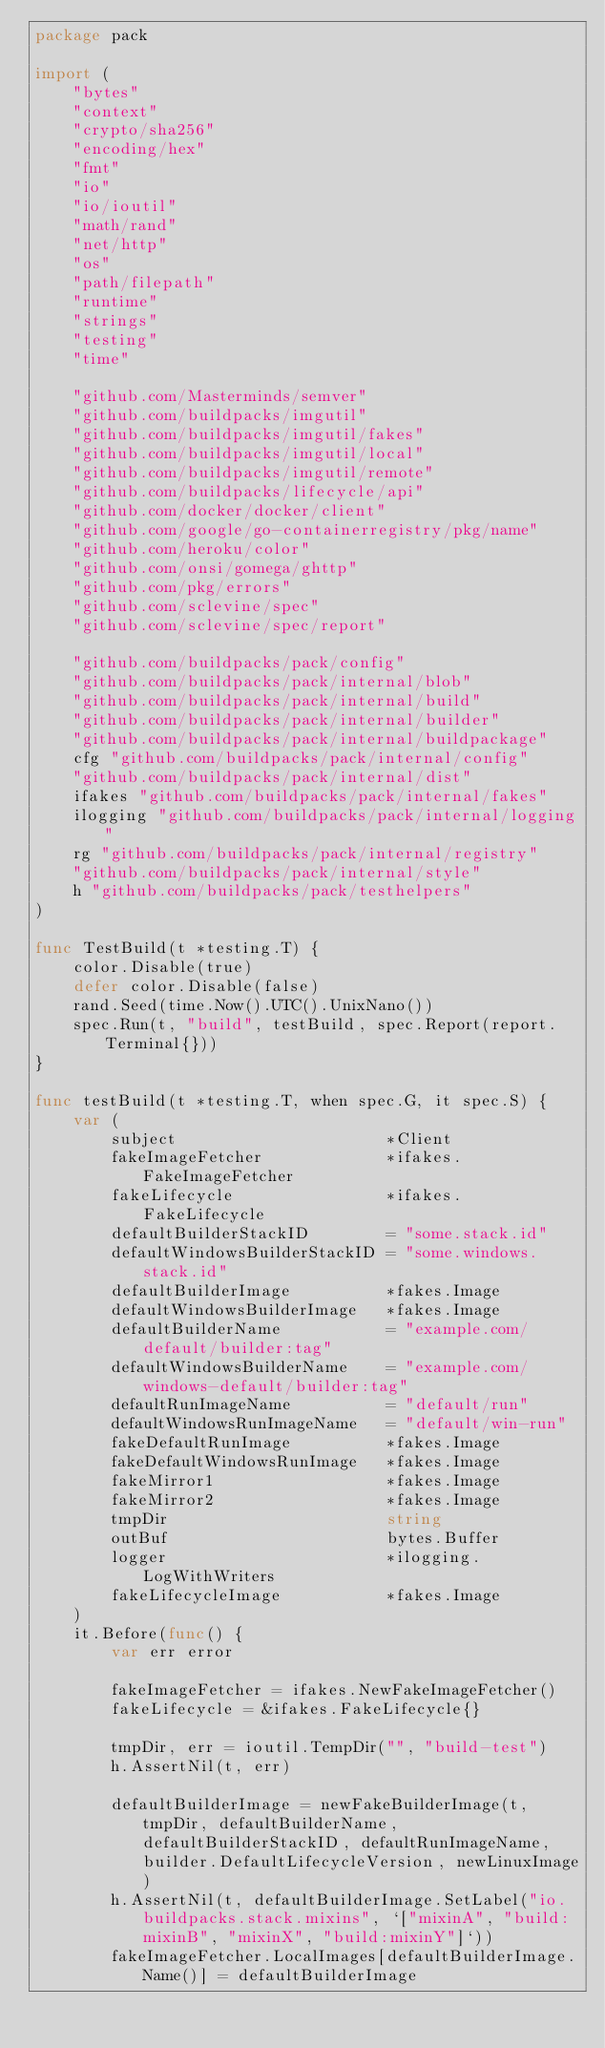<code> <loc_0><loc_0><loc_500><loc_500><_Go_>package pack

import (
	"bytes"
	"context"
	"crypto/sha256"
	"encoding/hex"
	"fmt"
	"io"
	"io/ioutil"
	"math/rand"
	"net/http"
	"os"
	"path/filepath"
	"runtime"
	"strings"
	"testing"
	"time"

	"github.com/Masterminds/semver"
	"github.com/buildpacks/imgutil"
	"github.com/buildpacks/imgutil/fakes"
	"github.com/buildpacks/imgutil/local"
	"github.com/buildpacks/imgutil/remote"
	"github.com/buildpacks/lifecycle/api"
	"github.com/docker/docker/client"
	"github.com/google/go-containerregistry/pkg/name"
	"github.com/heroku/color"
	"github.com/onsi/gomega/ghttp"
	"github.com/pkg/errors"
	"github.com/sclevine/spec"
	"github.com/sclevine/spec/report"

	"github.com/buildpacks/pack/config"
	"github.com/buildpacks/pack/internal/blob"
	"github.com/buildpacks/pack/internal/build"
	"github.com/buildpacks/pack/internal/builder"
	"github.com/buildpacks/pack/internal/buildpackage"
	cfg "github.com/buildpacks/pack/internal/config"
	"github.com/buildpacks/pack/internal/dist"
	ifakes "github.com/buildpacks/pack/internal/fakes"
	ilogging "github.com/buildpacks/pack/internal/logging"
	rg "github.com/buildpacks/pack/internal/registry"
	"github.com/buildpacks/pack/internal/style"
	h "github.com/buildpacks/pack/testhelpers"
)

func TestBuild(t *testing.T) {
	color.Disable(true)
	defer color.Disable(false)
	rand.Seed(time.Now().UTC().UnixNano())
	spec.Run(t, "build", testBuild, spec.Report(report.Terminal{}))
}

func testBuild(t *testing.T, when spec.G, it spec.S) {
	var (
		subject                      *Client
		fakeImageFetcher             *ifakes.FakeImageFetcher
		fakeLifecycle                *ifakes.FakeLifecycle
		defaultBuilderStackID        = "some.stack.id"
		defaultWindowsBuilderStackID = "some.windows.stack.id"
		defaultBuilderImage          *fakes.Image
		defaultWindowsBuilderImage   *fakes.Image
		defaultBuilderName           = "example.com/default/builder:tag"
		defaultWindowsBuilderName    = "example.com/windows-default/builder:tag"
		defaultRunImageName          = "default/run"
		defaultWindowsRunImageName   = "default/win-run"
		fakeDefaultRunImage          *fakes.Image
		fakeDefaultWindowsRunImage   *fakes.Image
		fakeMirror1                  *fakes.Image
		fakeMirror2                  *fakes.Image
		tmpDir                       string
		outBuf                       bytes.Buffer
		logger                       *ilogging.LogWithWriters
		fakeLifecycleImage           *fakes.Image
	)
	it.Before(func() {
		var err error

		fakeImageFetcher = ifakes.NewFakeImageFetcher()
		fakeLifecycle = &ifakes.FakeLifecycle{}

		tmpDir, err = ioutil.TempDir("", "build-test")
		h.AssertNil(t, err)

		defaultBuilderImage = newFakeBuilderImage(t, tmpDir, defaultBuilderName, defaultBuilderStackID, defaultRunImageName, builder.DefaultLifecycleVersion, newLinuxImage)
		h.AssertNil(t, defaultBuilderImage.SetLabel("io.buildpacks.stack.mixins", `["mixinA", "build:mixinB", "mixinX", "build:mixinY"]`))
		fakeImageFetcher.LocalImages[defaultBuilderImage.Name()] = defaultBuilderImage
</code> 